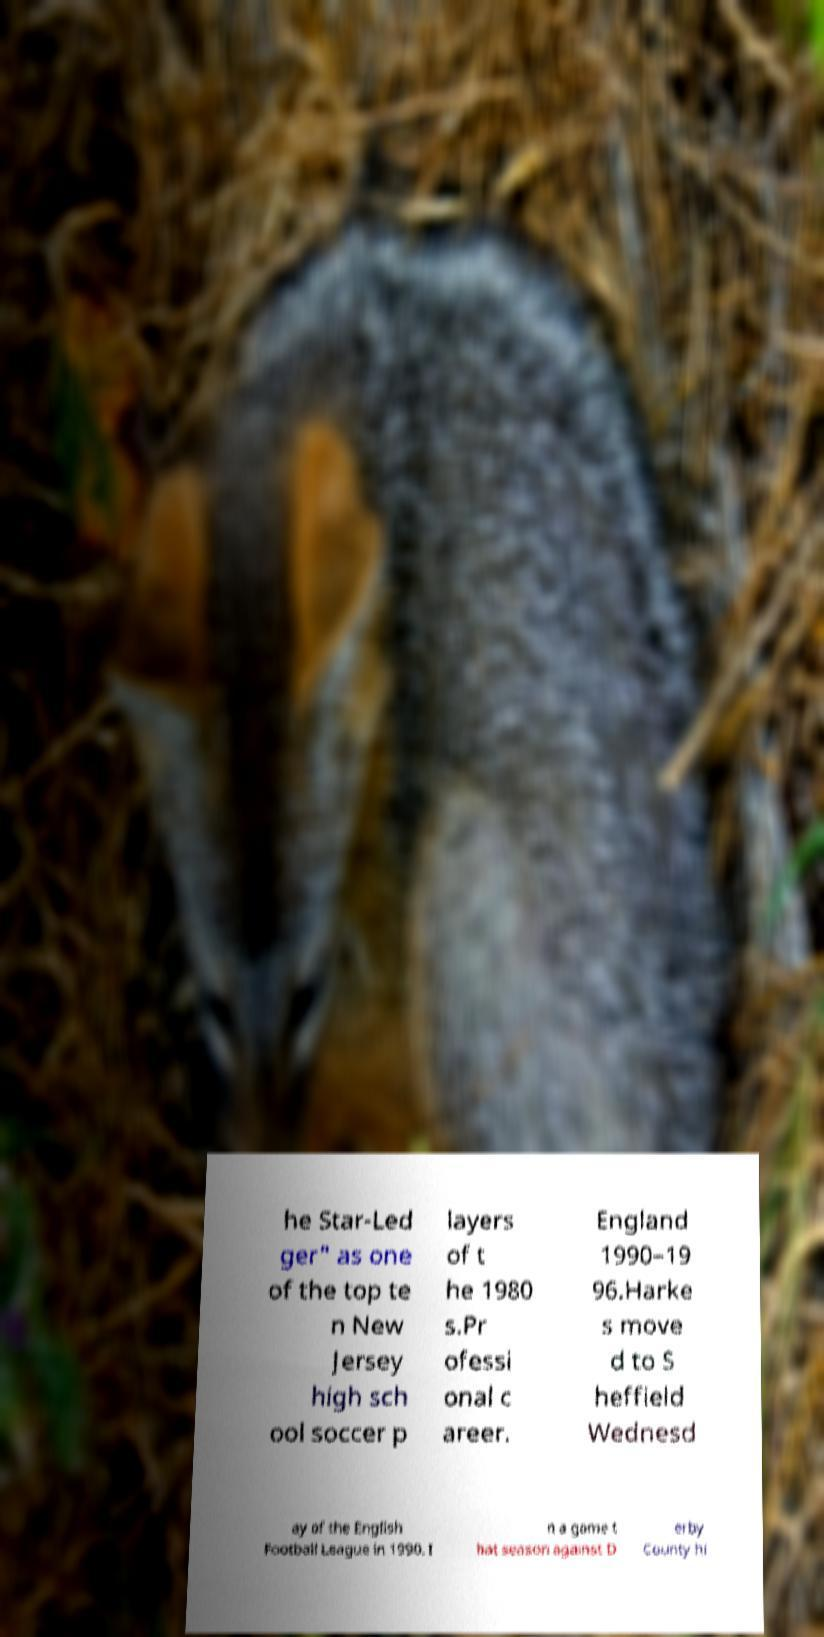Please identify and transcribe the text found in this image. he Star-Led ger" as one of the top te n New Jersey high sch ool soccer p layers of t he 1980 s.Pr ofessi onal c areer. England 1990–19 96.Harke s move d to S heffield Wednesd ay of the English Football League in 1990. I n a game t hat season against D erby County hi 